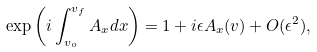Convert formula to latex. <formula><loc_0><loc_0><loc_500><loc_500>\exp \left ( i \int _ { v _ { o } } ^ { v _ { f } } A _ { x } d x \right ) = 1 + i \epsilon A _ { x } ( v ) + O ( \epsilon ^ { 2 } ) ,</formula> 